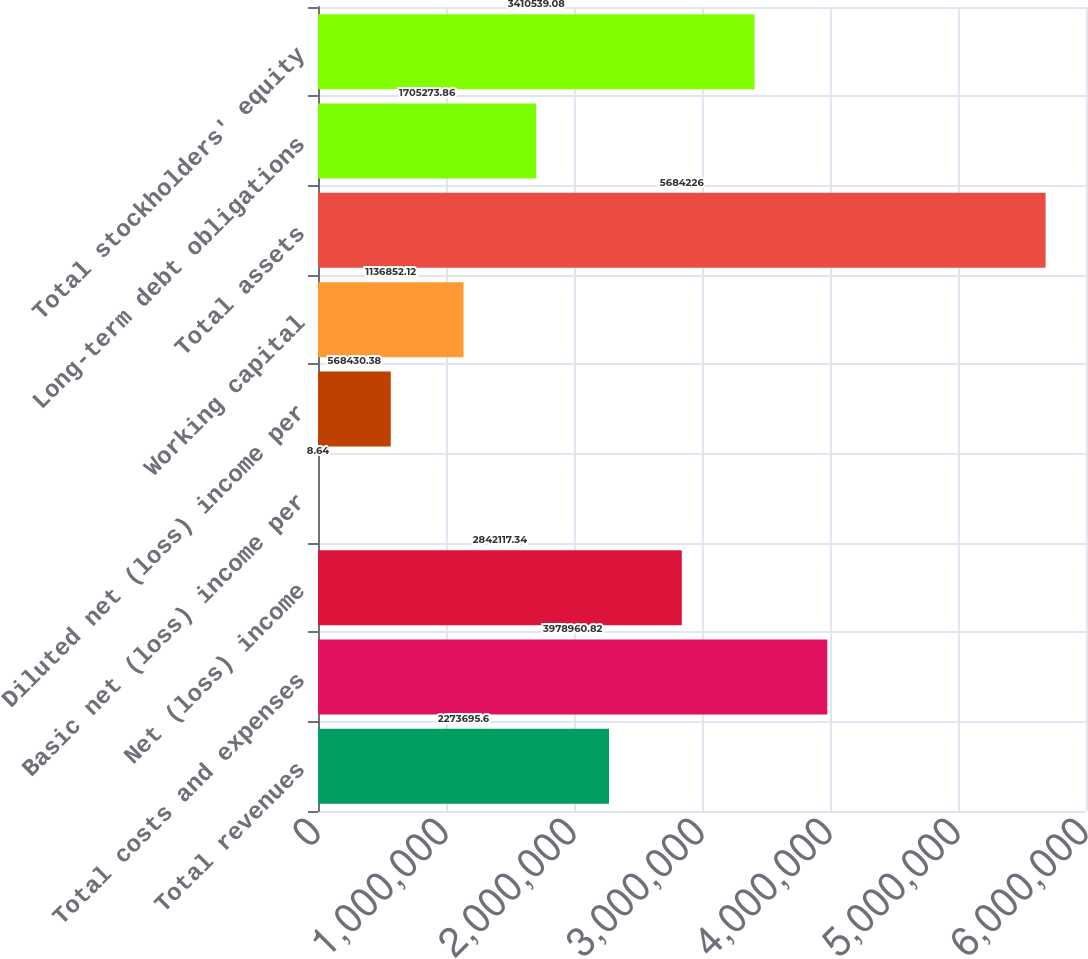Convert chart to OTSL. <chart><loc_0><loc_0><loc_500><loc_500><bar_chart><fcel>Total revenues<fcel>Total costs and expenses<fcel>Net (loss) income<fcel>Basic net (loss) income per<fcel>Diluted net (loss) income per<fcel>Working capital<fcel>Total assets<fcel>Long-term debt obligations<fcel>Total stockholders' equity<nl><fcel>2.2737e+06<fcel>3.97896e+06<fcel>2.84212e+06<fcel>8.64<fcel>568430<fcel>1.13685e+06<fcel>5.68423e+06<fcel>1.70527e+06<fcel>3.41054e+06<nl></chart> 